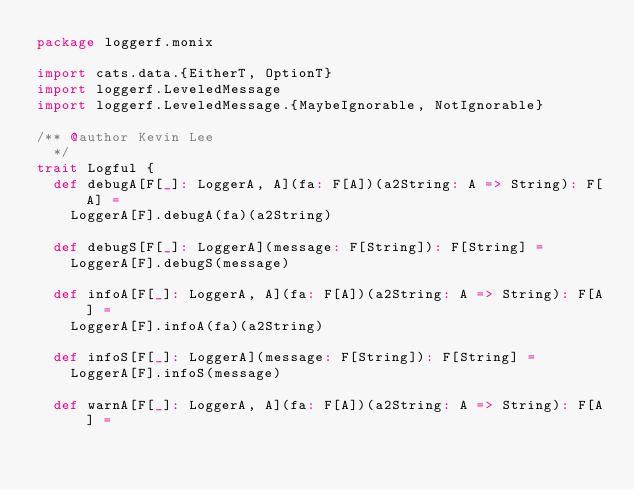<code> <loc_0><loc_0><loc_500><loc_500><_Scala_>package loggerf.monix

import cats.data.{EitherT, OptionT}
import loggerf.LeveledMessage
import loggerf.LeveledMessage.{MaybeIgnorable, NotIgnorable}

/** @author Kevin Lee
  */
trait Logful {
  def debugA[F[_]: LoggerA, A](fa: F[A])(a2String: A => String): F[A] =
    LoggerA[F].debugA(fa)(a2String)

  def debugS[F[_]: LoggerA](message: F[String]): F[String] =
    LoggerA[F].debugS(message)

  def infoA[F[_]: LoggerA, A](fa: F[A])(a2String: A => String): F[A] =
    LoggerA[F].infoA(fa)(a2String)

  def infoS[F[_]: LoggerA](message: F[String]): F[String] =
    LoggerA[F].infoS(message)

  def warnA[F[_]: LoggerA, A](fa: F[A])(a2String: A => String): F[A] =</code> 